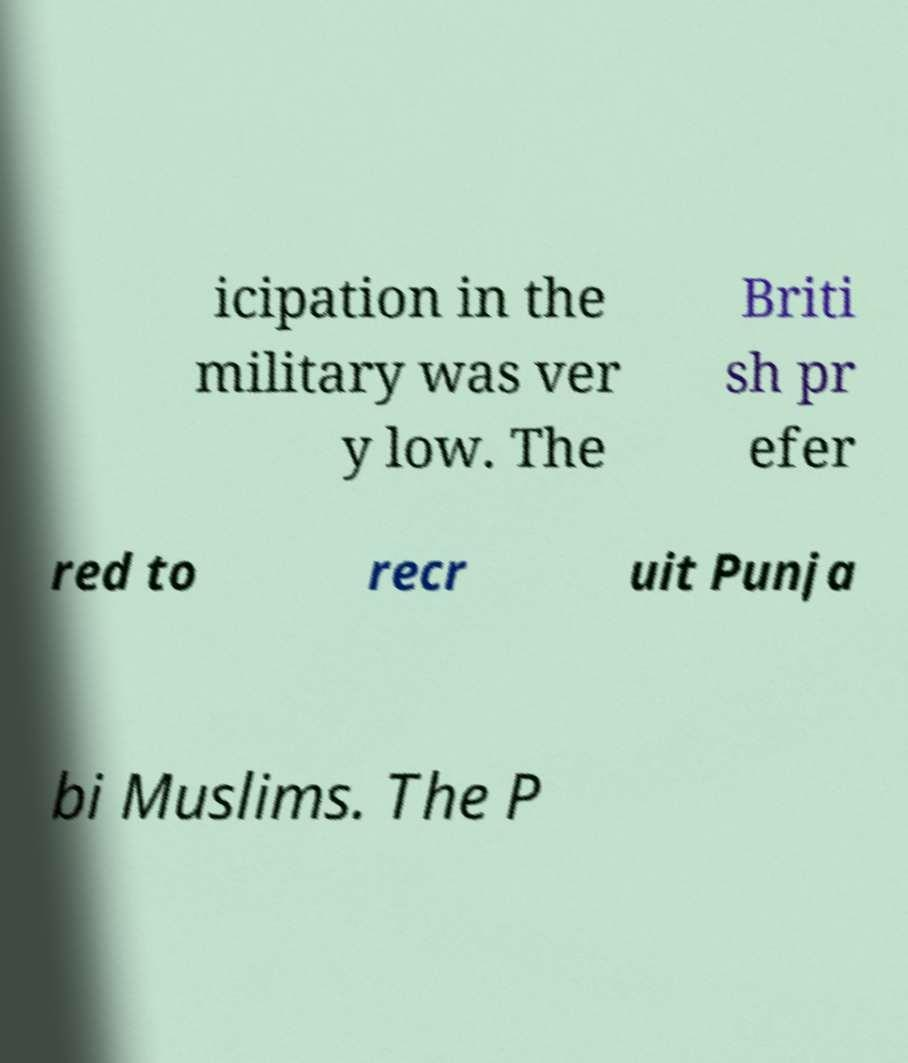Please identify and transcribe the text found in this image. icipation in the military was ver y low. The Briti sh pr efer red to recr uit Punja bi Muslims. The P 